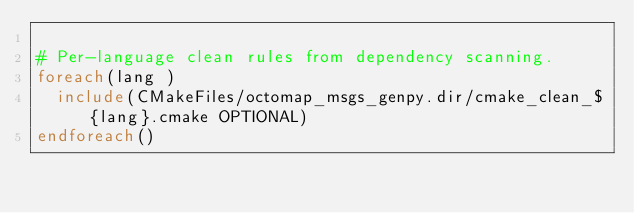<code> <loc_0><loc_0><loc_500><loc_500><_CMake_>
# Per-language clean rules from dependency scanning.
foreach(lang )
  include(CMakeFiles/octomap_msgs_genpy.dir/cmake_clean_${lang}.cmake OPTIONAL)
endforeach()
</code> 